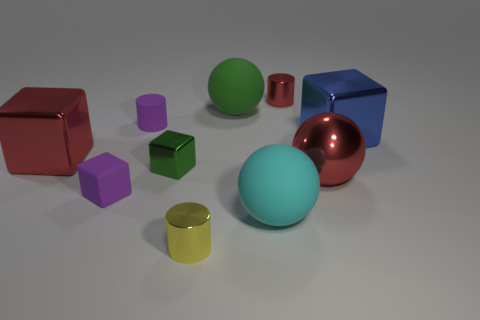Subtract all matte spheres. How many spheres are left? 1 Subtract all balls. How many objects are left? 7 Subtract all cyan cubes. How many red spheres are left? 1 Subtract all red blocks. How many blocks are left? 3 Subtract 1 cylinders. How many cylinders are left? 2 Add 4 blue blocks. How many blue blocks are left? 5 Add 5 small blocks. How many small blocks exist? 7 Subtract 1 yellow cylinders. How many objects are left? 9 Subtract all purple balls. Subtract all yellow cylinders. How many balls are left? 3 Subtract all cyan rubber balls. Subtract all small red objects. How many objects are left? 8 